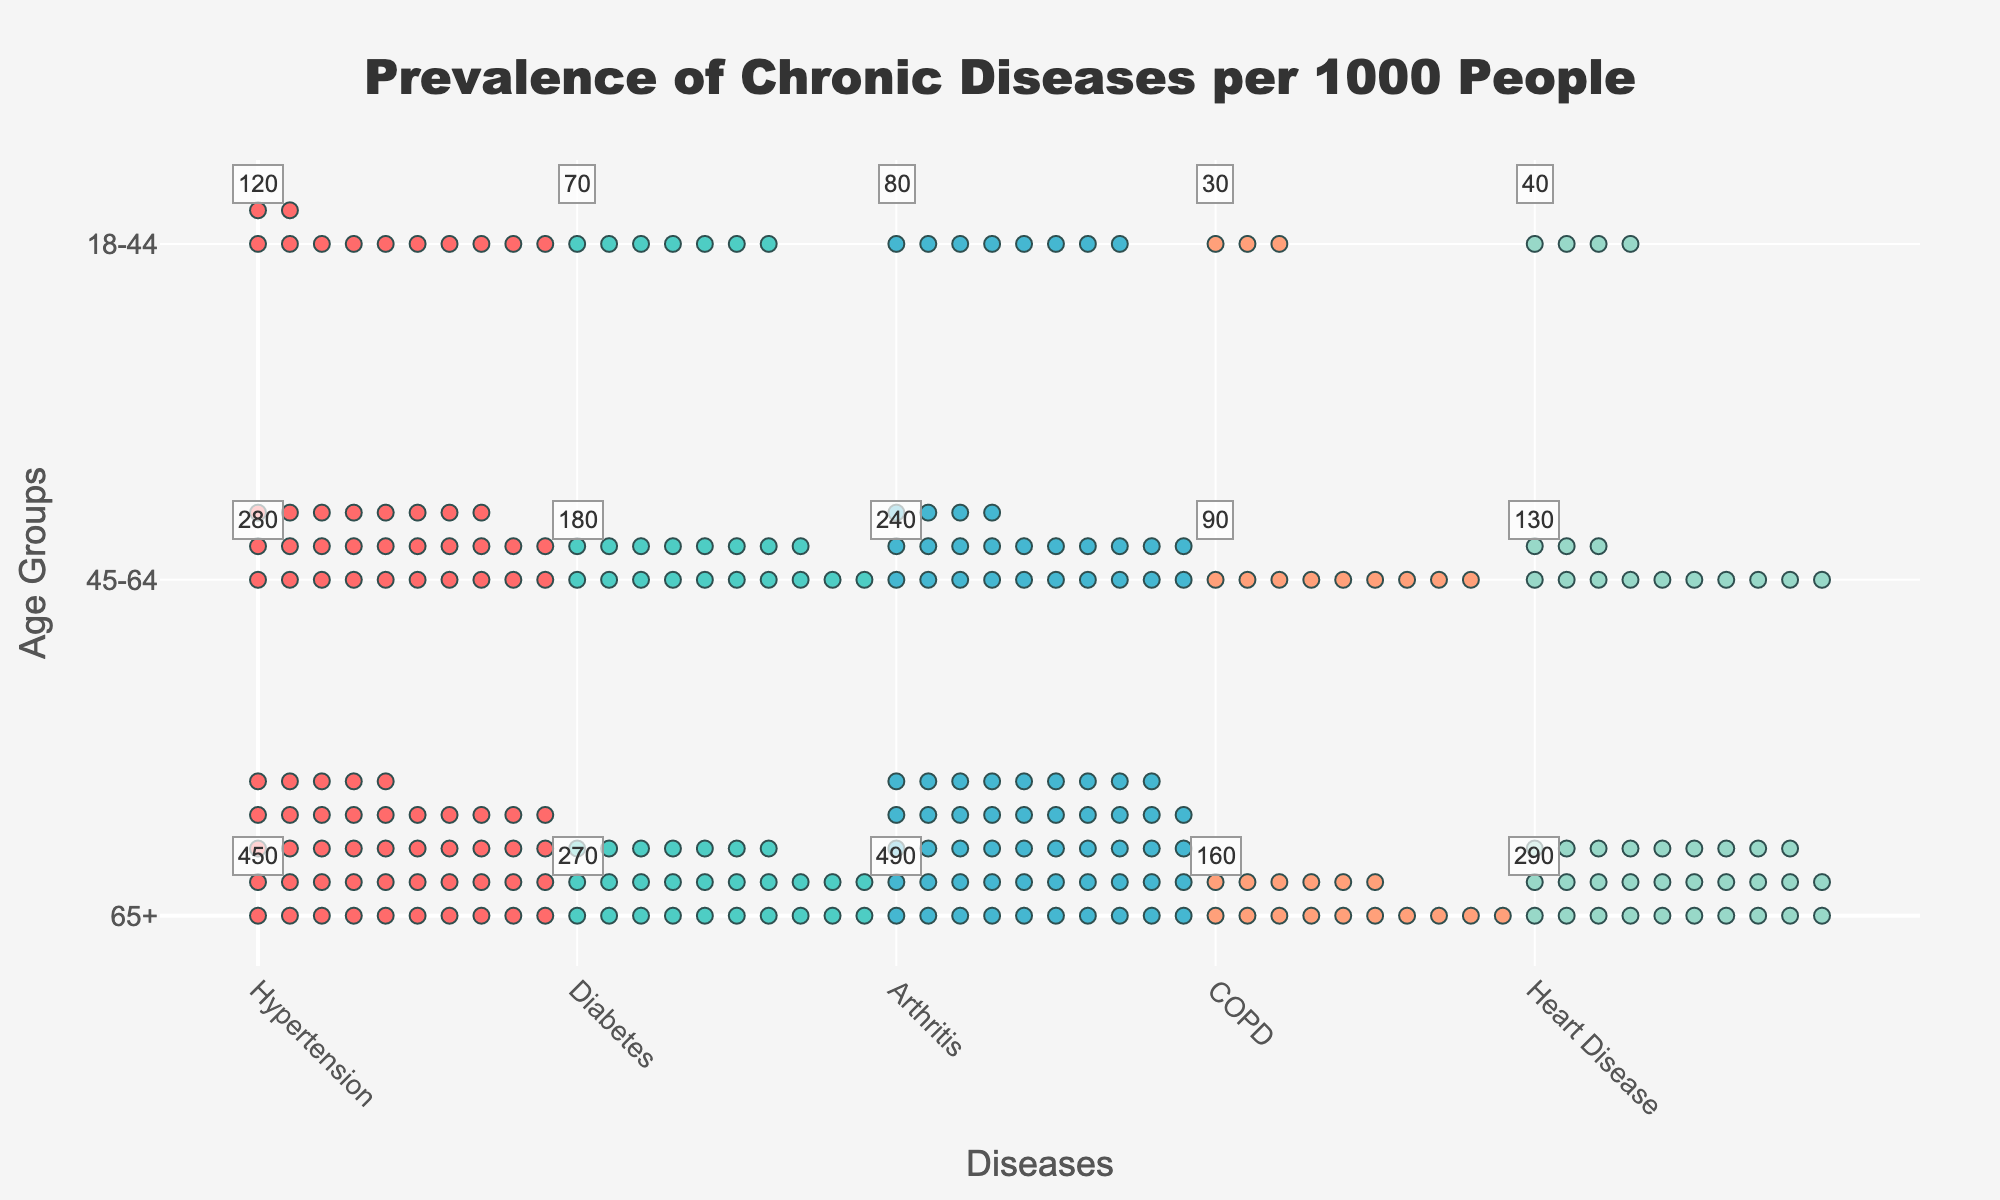What's the title of the figure? The title is located at the top center of the figure. It reads, "Prevalence of Chronic Diseases per 1000 People".
Answer: Prevalence of Chronic Diseases per 1000 People Which disease has the highest prevalence in the 65+ age group? By looking at the top row for each age group, we spot the highest number of icons in the "Arthritis" column. The annotation confirms a prevalence of 490 per 1000 people for Arthritis in the 65+ age group.
Answer: Arthritis What is the difference in prevalence of Diabetes between the 18-44 and 65+ age groups? Identify the prevalence annotations for Diabetes in both age groups from the figure: 270 per 1000 for 65+ and 70 per 1000 for 18-44. Calculate the difference: 270 - 70 = 200.
Answer: 200 per 1000 How many chronic diseases are represented in the figure? Look along the x-axis labeled "Diseases" to count the number of distinct diseases listed. The diseases present are Hypertension, Diabetes, Arthritis, COPD, and Heart Disease, making a total of five diseases.
Answer: 5 Which age group has the lowest prevalence of Hypertension? Compare the prevalence annotations for Hypertension across the age groups. The values are 450 (65+), 280 (45-64), and 120 (18-44). The lowest value is 120, belonging to the 18-44 age group.
Answer: 18-44 What is the total prevalence of Heart Disease across all age groups? Sum the prevalence values of Heart Disease for each age group from the annotations: 290 (65+), 130 (45-64), and 40 (18-44). Total: 290 + 130 + 40 = 460.
Answer: 460 per 1000 Which disease has a prevalence of 90 per 1000 in the 45-64 age group? Locate the 45-64 (middle) row and find the number 90 within the prevalence annotations. It corresponds to COPD.
Answer: COPD Is there any age group where each disease has the same prevalence? Check the prevalence annotations for all diseases within each age group. The 65+, 45-64, and 18-44 age groups each have varying prevalence values for different diseases, indicating no same prevalence.
Answer: No Which age group shows the highest average prevalence across all diseases? Calculate the average prevalence across all diseases for each age group:
- 65+: (450 + 270 + 490 + 160 + 290)/5 = 332
- 45-64: (280 + 180 + 240 + 90 + 130)/5 = 184
- 18-44: (120 + 70 + 80 + 30 + 40)/5 = 68
The highest average is for the 65+ age group.
Answer: 65+ How does the prevalence of Arthritis in the 45-64 age group compare to the prevalence of Hypertension in the 18-44 age group? Compare the annotated values: Arthritis in 45-64 is 240 per 1000 and Hypertension in 18-44 is 120 per 1000. Arthritis in the 45-64 age group is higher.
Answer: Arthritis in 45-64 is higher 